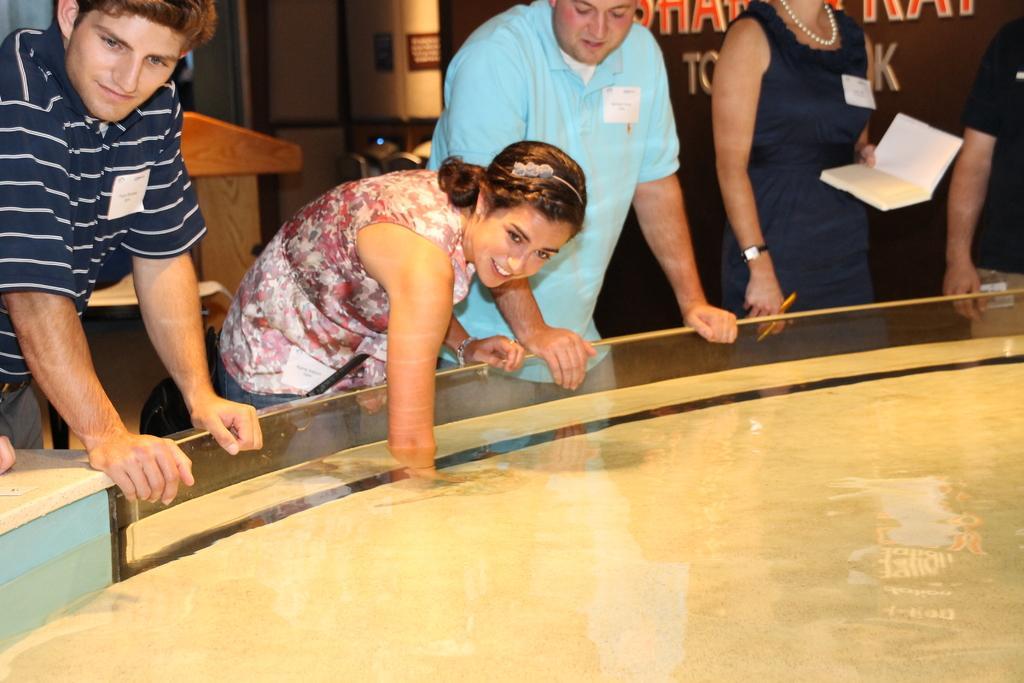How would you summarize this image in a sentence or two? In the picture there is a container present with the liquid, inside the container there are people standing, there is a woman keeping hand in the liquid, another woman is holding a pen and a book with the hands, behind them there is some text present, there is a wall. 